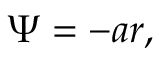Convert formula to latex. <formula><loc_0><loc_0><loc_500><loc_500>\Psi = - a r ,</formula> 